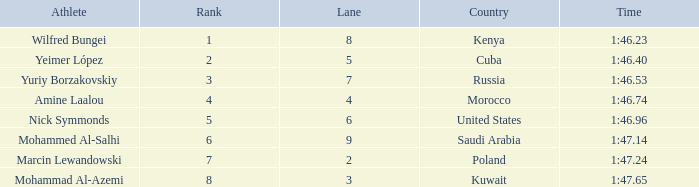What is the Rank of the Athlete with a Time of 1:47.65 and in Lane 3 or larger? None. 